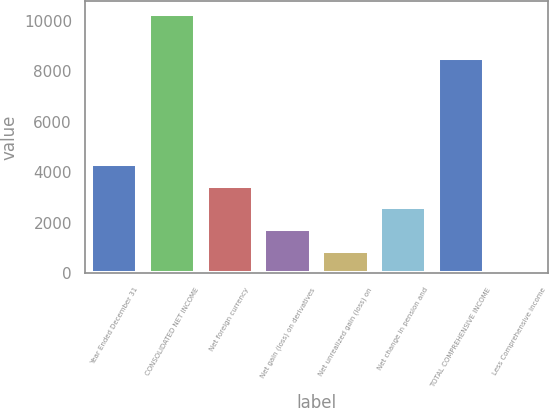Convert chart to OTSL. <chart><loc_0><loc_0><loc_500><loc_500><bar_chart><fcel>Year Ended December 31<fcel>CONSOLIDATED NET INCOME<fcel>Net foreign currency<fcel>Net gain (loss) on derivatives<fcel>Net unrealized gain (loss) on<fcel>Net change in pension and<fcel>TOTAL COMPREHENSIVE INCOME<fcel>Less Comprehensive income<nl><fcel>4332.5<fcel>10254.4<fcel>3473.8<fcel>1756.4<fcel>897.7<fcel>2615.1<fcel>8537<fcel>39<nl></chart> 